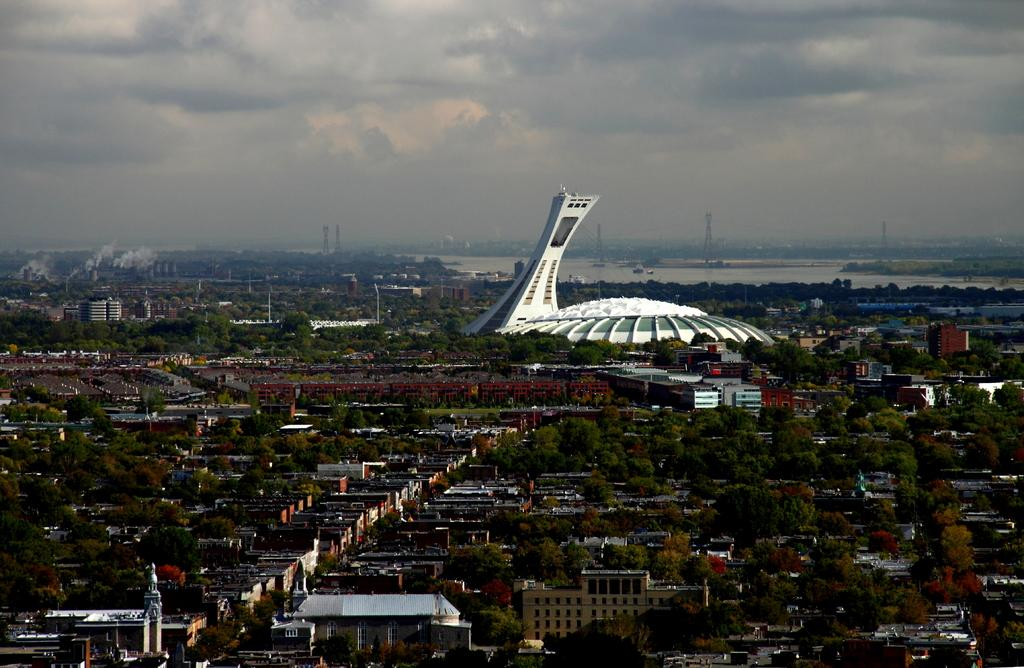What type of structures can be seen in the image? There are houses in the image. What other natural elements are present in the image? There are trees in the image. What is the prominent feature in the middle of the image? There is a white color construction in the middle of the image. What is visible in the background of the image? The sky is visible in the image. How would you describe the weather based on the sky in the image? The sky appears to be cloudy in the image. Can you see a crown on top of the white construction in the image? There is no crown present on top of the white construction in the image. How much money is being exchanged between the houses in the image? There is no indication of any money exchange between the houses in the image. 